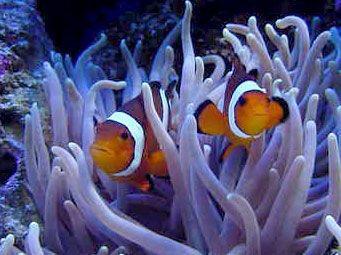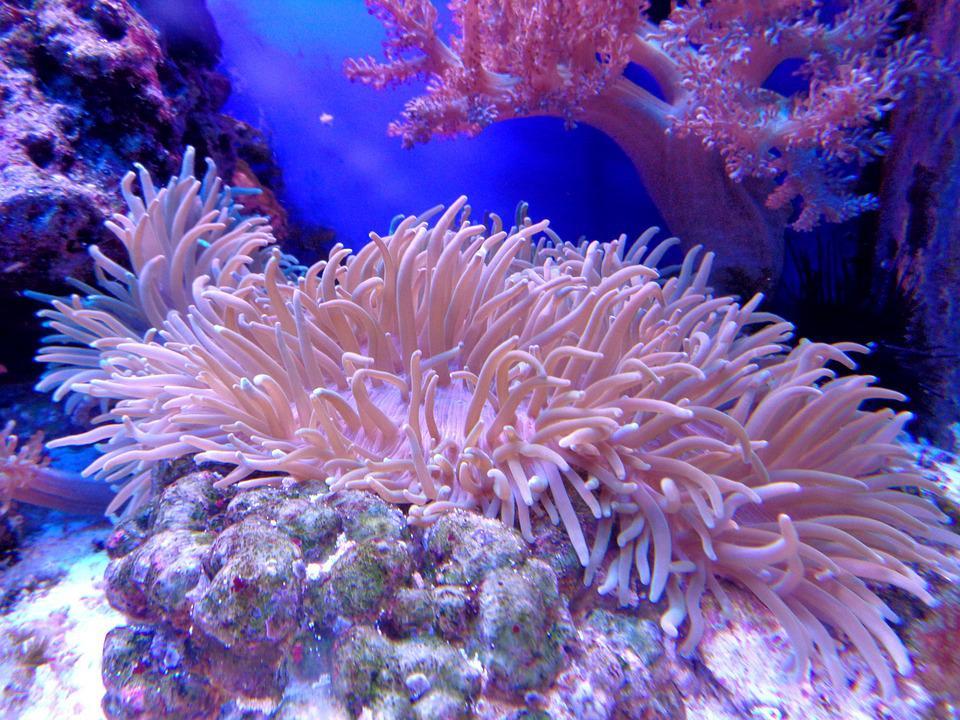The first image is the image on the left, the second image is the image on the right. Assess this claim about the two images: "There are two clown fish in total.". Correct or not? Answer yes or no. Yes. The first image is the image on the left, the second image is the image on the right. Analyze the images presented: Is the assertion "An image shows exactly two clown fish swimming by a neutral-colored anemone." valid? Answer yes or no. Yes. 